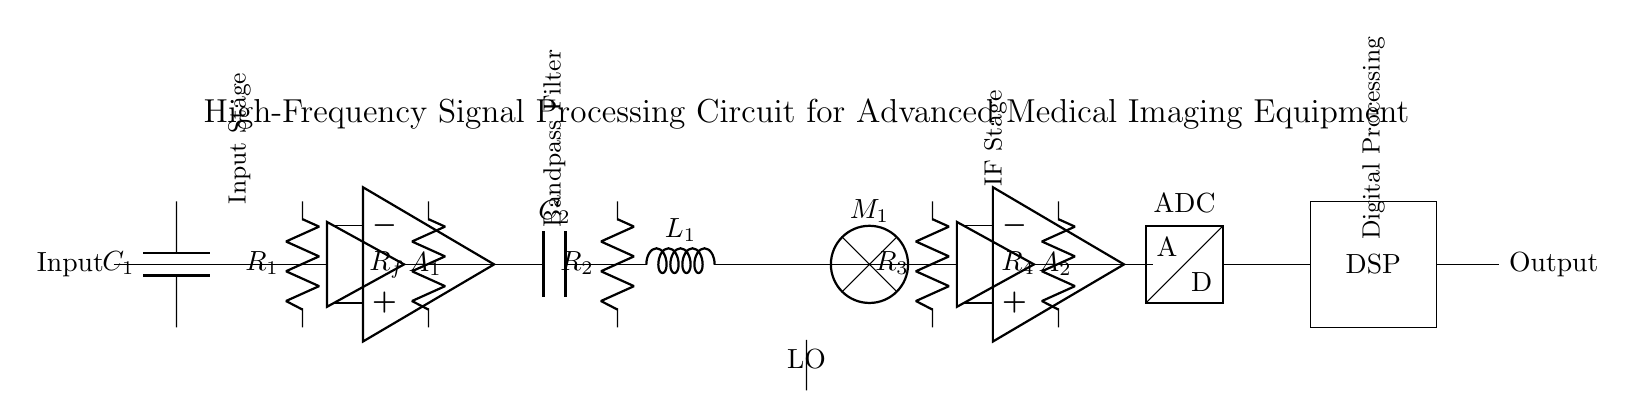What component is used for signal amplification? The circuit includes two operational amplifiers labeled as A1 and A2, both responsible for amplifying the input signal at different stages of the processing.
Answer: Operational amplifier What is the function of the capacitor C2? C2 is part of the bandpass filter section, which allows specific frequency signals to pass while blocking others, effectively tuning the circuit to desired frequencies.
Answer: Bandpass filtering How many resistors are present in the circuit? There are four resistors in total, designated as R1, R2, R3, and R4, which play roles in setting gain and filtering signals throughout the circuit.
Answer: Four What is the output of the circuit? The output is generated from the final stage of the circuit, which includes a digital signal processor, indicating the processed signal ready for use in medical imaging applications.
Answer: Digital signal What type of mixer is used in the circuit? The mixer denoted as M1 is utilized to combine the incoming signal with a local oscillator, facilitating frequency conversion within the signal processing chain.
Answer: Mixer What role does the ADC play in this circuit? The ADC, or analog-to-digital converter, converts the analog signals processed by the preceding components into digital signals for further digital processing, ensuring accurate data representation.
Answer: Conversion to digital What does the acronym DSP stand for in this context? DSP stands for digital signal processor, which is a specialized computing device designed for analyzing, manipulating, and optimizing signals in digital form, crucial for advanced medical imaging.
Answer: Digital signal processor 